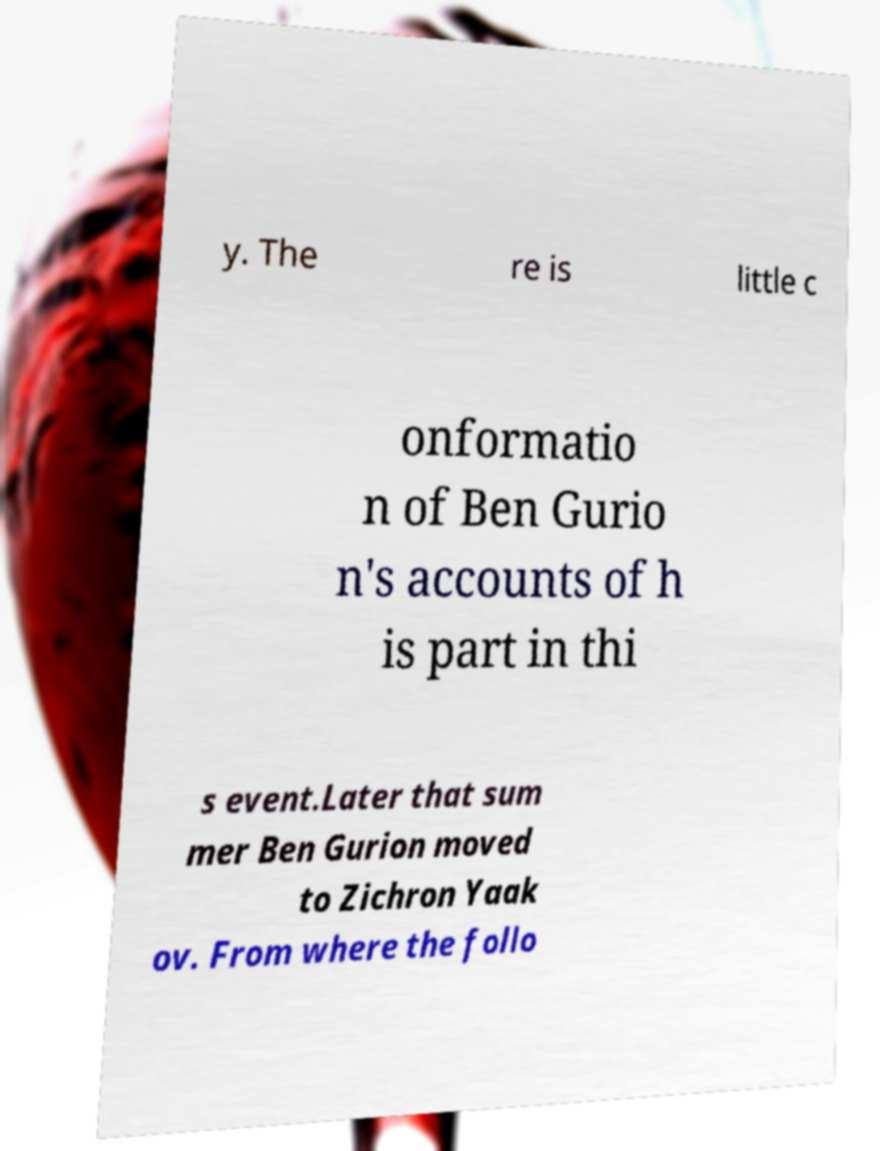I need the written content from this picture converted into text. Can you do that? y. The re is little c onformatio n of Ben Gurio n's accounts of h is part in thi s event.Later that sum mer Ben Gurion moved to Zichron Yaak ov. From where the follo 